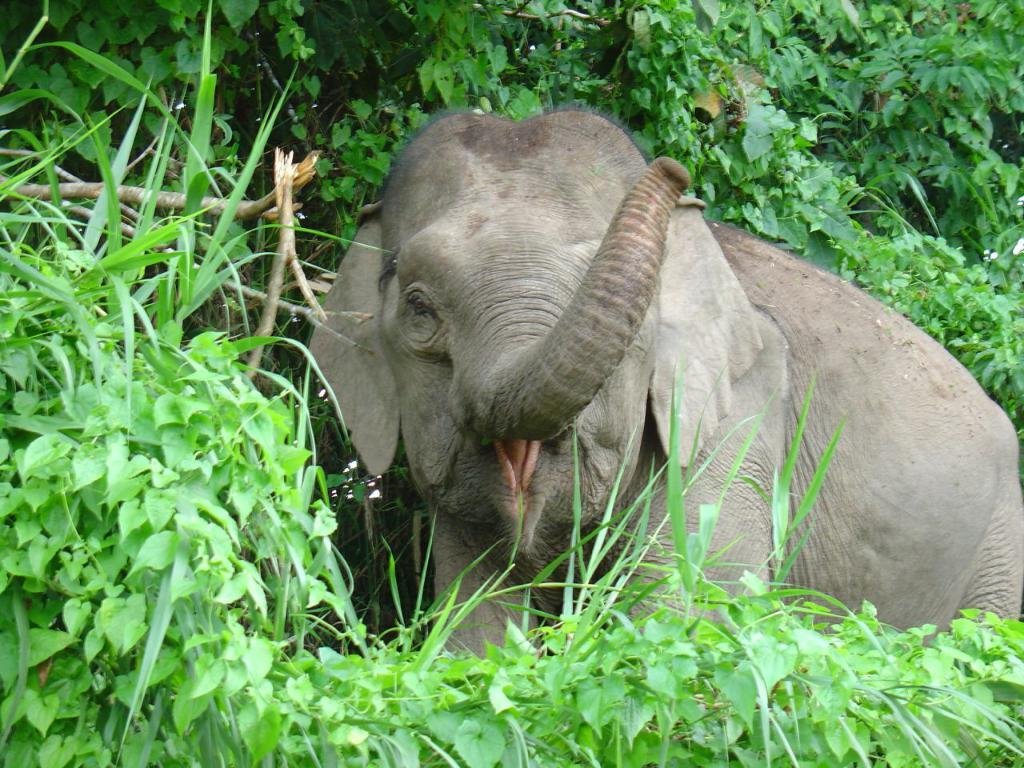What animal is the main subject of the picture? There is an elephant in the picture. What can be seen in the background of the picture? There are trees behind the elephant. What parts of the trees are visible in the picture? There are branches visible in the picture. What type of religion is being practiced by the elephant in the picture? There is no indication of any religious practice in the image, as it features an elephant and trees. --- Facts: 1. There is a car in the picture. 2. The car is red. 3. The car has four wheels. 4. There are people in the car. 5. The car is parked on the street. Absurd Topics: ocean, birdhouse, volcano Conversation: What type of vehicle is in the picture? There is a car in the picture. What color is the car? The car is red. How many wheels does the car have? The car has four wheels. Who is inside the car? There are people in the car. Where is the car located in the picture? The car is parked on the street. Reasoning: Let's think step by step in order to produce the conversation. We start by identifying the main subject of the image, which is the car. Then, we describe specific details about the car, such as its color and the number of wheels. Next, we mention the presence of people inside the car. Finally, we describe the car's location in the picture, which is parked on the street. Each question is designed to elicit a specific detail about the image that is known from the provided facts. Absurd Question/Answer: Can you see any ocean waves crashing against the car in the picture? There is no ocean or waves present in the image; it features a red car parked on the street. 